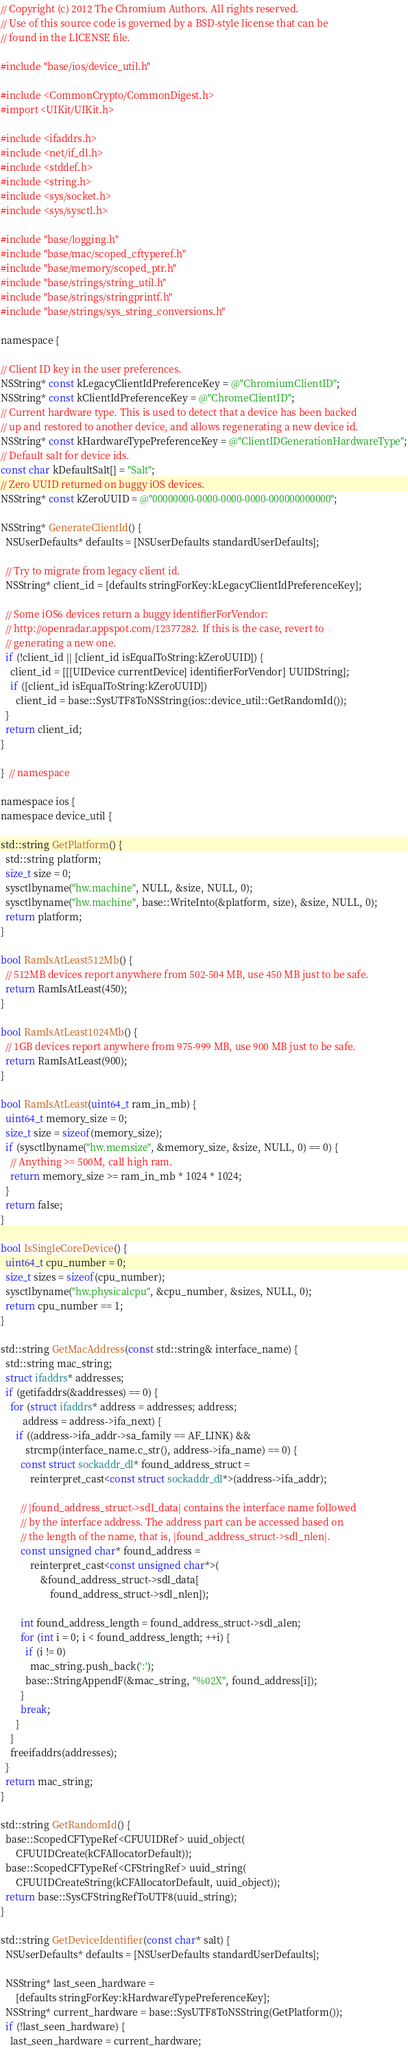Convert code to text. <code><loc_0><loc_0><loc_500><loc_500><_ObjectiveC_>// Copyright (c) 2012 The Chromium Authors. All rights reserved.
// Use of this source code is governed by a BSD-style license that can be
// found in the LICENSE file.

#include "base/ios/device_util.h"

#include <CommonCrypto/CommonDigest.h>
#import <UIKit/UIKit.h>

#include <ifaddrs.h>
#include <net/if_dl.h>
#include <stddef.h>
#include <string.h>
#include <sys/socket.h>
#include <sys/sysctl.h>

#include "base/logging.h"
#include "base/mac/scoped_cftyperef.h"
#include "base/memory/scoped_ptr.h"
#include "base/strings/string_util.h"
#include "base/strings/stringprintf.h"
#include "base/strings/sys_string_conversions.h"

namespace {

// Client ID key in the user preferences.
NSString* const kLegacyClientIdPreferenceKey = @"ChromiumClientID";
NSString* const kClientIdPreferenceKey = @"ChromeClientID";
// Current hardware type. This is used to detect that a device has been backed
// up and restored to another device, and allows regenerating a new device id.
NSString* const kHardwareTypePreferenceKey = @"ClientIDGenerationHardwareType";
// Default salt for device ids.
const char kDefaultSalt[] = "Salt";
// Zero UUID returned on buggy iOS devices.
NSString* const kZeroUUID = @"00000000-0000-0000-0000-000000000000";

NSString* GenerateClientId() {
  NSUserDefaults* defaults = [NSUserDefaults standardUserDefaults];

  // Try to migrate from legacy client id.
  NSString* client_id = [defaults stringForKey:kLegacyClientIdPreferenceKey];

  // Some iOS6 devices return a buggy identifierForVendor:
  // http://openradar.appspot.com/12377282. If this is the case, revert to
  // generating a new one.
  if (!client_id || [client_id isEqualToString:kZeroUUID]) {
    client_id = [[[UIDevice currentDevice] identifierForVendor] UUIDString];
    if ([client_id isEqualToString:kZeroUUID])
      client_id = base::SysUTF8ToNSString(ios::device_util::GetRandomId());
  }
  return client_id;
}

}  // namespace

namespace ios {
namespace device_util {

std::string GetPlatform() {
  std::string platform;
  size_t size = 0;
  sysctlbyname("hw.machine", NULL, &size, NULL, 0);
  sysctlbyname("hw.machine", base::WriteInto(&platform, size), &size, NULL, 0);
  return platform;
}

bool RamIsAtLeast512Mb() {
  // 512MB devices report anywhere from 502-504 MB, use 450 MB just to be safe.
  return RamIsAtLeast(450);
}

bool RamIsAtLeast1024Mb() {
  // 1GB devices report anywhere from 975-999 MB, use 900 MB just to be safe.
  return RamIsAtLeast(900);
}

bool RamIsAtLeast(uint64_t ram_in_mb) {
  uint64_t memory_size = 0;
  size_t size = sizeof(memory_size);
  if (sysctlbyname("hw.memsize", &memory_size, &size, NULL, 0) == 0) {
    // Anything >= 500M, call high ram.
    return memory_size >= ram_in_mb * 1024 * 1024;
  }
  return false;
}

bool IsSingleCoreDevice() {
  uint64_t cpu_number = 0;
  size_t sizes = sizeof(cpu_number);
  sysctlbyname("hw.physicalcpu", &cpu_number, &sizes, NULL, 0);
  return cpu_number == 1;
}

std::string GetMacAddress(const std::string& interface_name) {
  std::string mac_string;
  struct ifaddrs* addresses;
  if (getifaddrs(&addresses) == 0) {
    for (struct ifaddrs* address = addresses; address;
         address = address->ifa_next) {
      if ((address->ifa_addr->sa_family == AF_LINK) &&
          strcmp(interface_name.c_str(), address->ifa_name) == 0) {
        const struct sockaddr_dl* found_address_struct =
            reinterpret_cast<const struct sockaddr_dl*>(address->ifa_addr);

        // |found_address_struct->sdl_data| contains the interface name followed
        // by the interface address. The address part can be accessed based on
        // the length of the name, that is, |found_address_struct->sdl_nlen|.
        const unsigned char* found_address =
            reinterpret_cast<const unsigned char*>(
                &found_address_struct->sdl_data[
                    found_address_struct->sdl_nlen]);

        int found_address_length = found_address_struct->sdl_alen;
        for (int i = 0; i < found_address_length; ++i) {
          if (i != 0)
            mac_string.push_back(':');
          base::StringAppendF(&mac_string, "%02X", found_address[i]);
        }
        break;
      }
    }
    freeifaddrs(addresses);
  }
  return mac_string;
}

std::string GetRandomId() {
  base::ScopedCFTypeRef<CFUUIDRef> uuid_object(
      CFUUIDCreate(kCFAllocatorDefault));
  base::ScopedCFTypeRef<CFStringRef> uuid_string(
      CFUUIDCreateString(kCFAllocatorDefault, uuid_object));
  return base::SysCFStringRefToUTF8(uuid_string);
}

std::string GetDeviceIdentifier(const char* salt) {
  NSUserDefaults* defaults = [NSUserDefaults standardUserDefaults];

  NSString* last_seen_hardware =
      [defaults stringForKey:kHardwareTypePreferenceKey];
  NSString* current_hardware = base::SysUTF8ToNSString(GetPlatform());
  if (!last_seen_hardware) {
    last_seen_hardware = current_hardware;</code> 